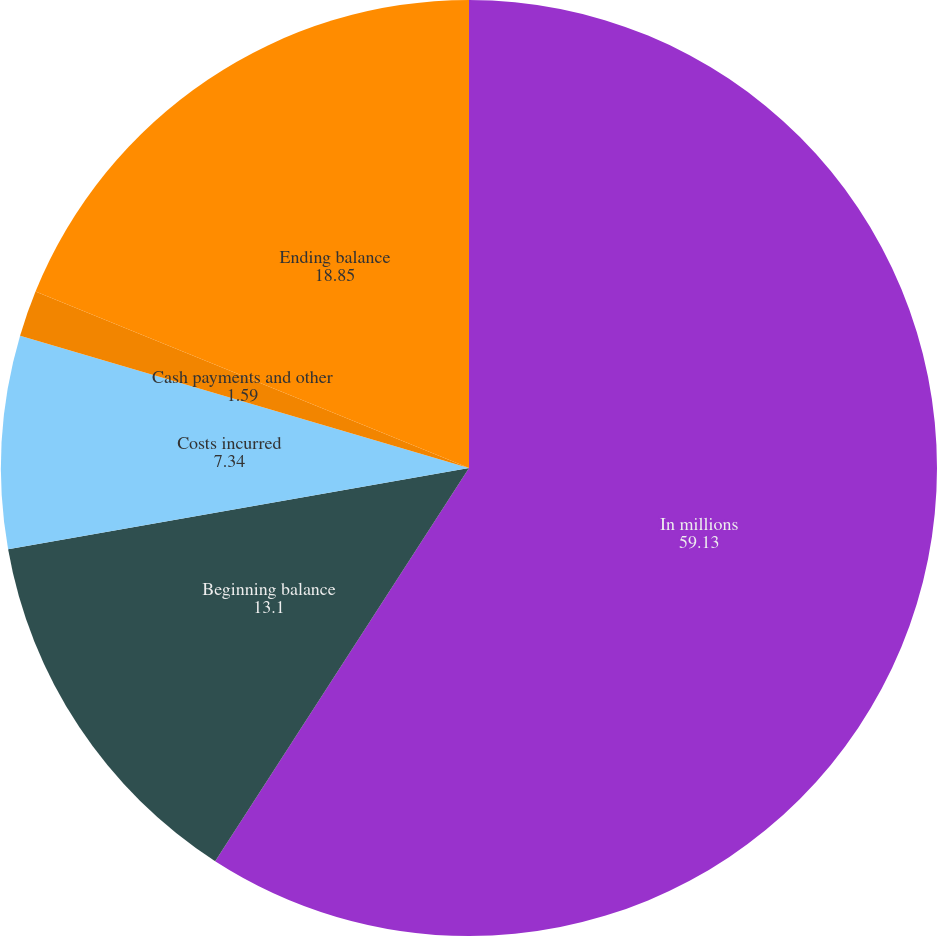Convert chart. <chart><loc_0><loc_0><loc_500><loc_500><pie_chart><fcel>In millions<fcel>Beginning balance<fcel>Costs incurred<fcel>Cash payments and other<fcel>Ending balance<nl><fcel>59.13%<fcel>13.1%<fcel>7.34%<fcel>1.59%<fcel>18.85%<nl></chart> 